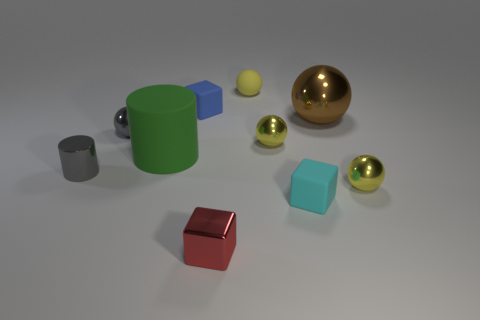Subtract all yellow balls. How many were subtracted if there are1yellow balls left? 2 Subtract all purple cylinders. How many yellow spheres are left? 3 Subtract all brown metal spheres. How many spheres are left? 4 Subtract all gray spheres. How many spheres are left? 4 Subtract all purple spheres. Subtract all blue cylinders. How many spheres are left? 5 Subtract all cubes. How many objects are left? 7 Subtract all large yellow rubber balls. Subtract all matte cylinders. How many objects are left? 9 Add 2 large objects. How many large objects are left? 4 Add 1 gray metallic cylinders. How many gray metallic cylinders exist? 2 Subtract 0 purple blocks. How many objects are left? 10 